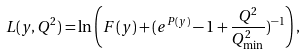<formula> <loc_0><loc_0><loc_500><loc_500>L ( y , Q ^ { 2 } ) = \ln \left ( F ( y ) + ( e ^ { P ( y ) } - 1 + \frac { Q ^ { 2 } } { Q ^ { 2 } _ { \min } } ) ^ { - 1 } \right ) ,</formula> 